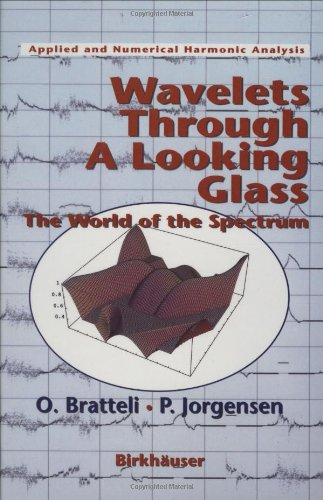Is this a religious book? No, this book is not related to religious studies; it is an academic text focused on wavelets and spectral theory within the fields of mathematics and physics. 